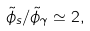Convert formula to latex. <formula><loc_0><loc_0><loc_500><loc_500>\tilde { \phi } _ { s } / \tilde { \phi } _ { \gamma } \simeq 2 ,</formula> 